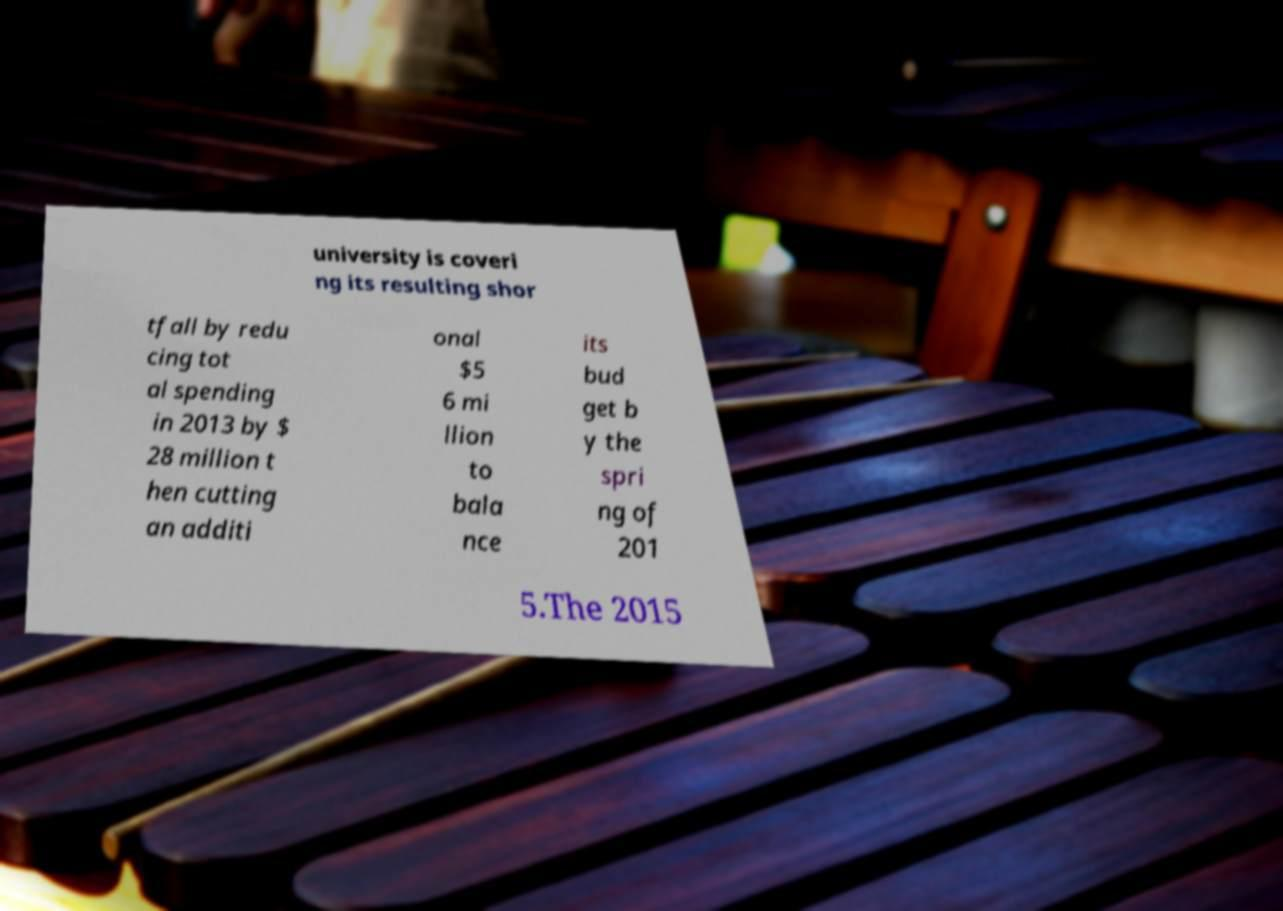Could you assist in decoding the text presented in this image and type it out clearly? university is coveri ng its resulting shor tfall by redu cing tot al spending in 2013 by $ 28 million t hen cutting an additi onal $5 6 mi llion to bala nce its bud get b y the spri ng of 201 5.The 2015 